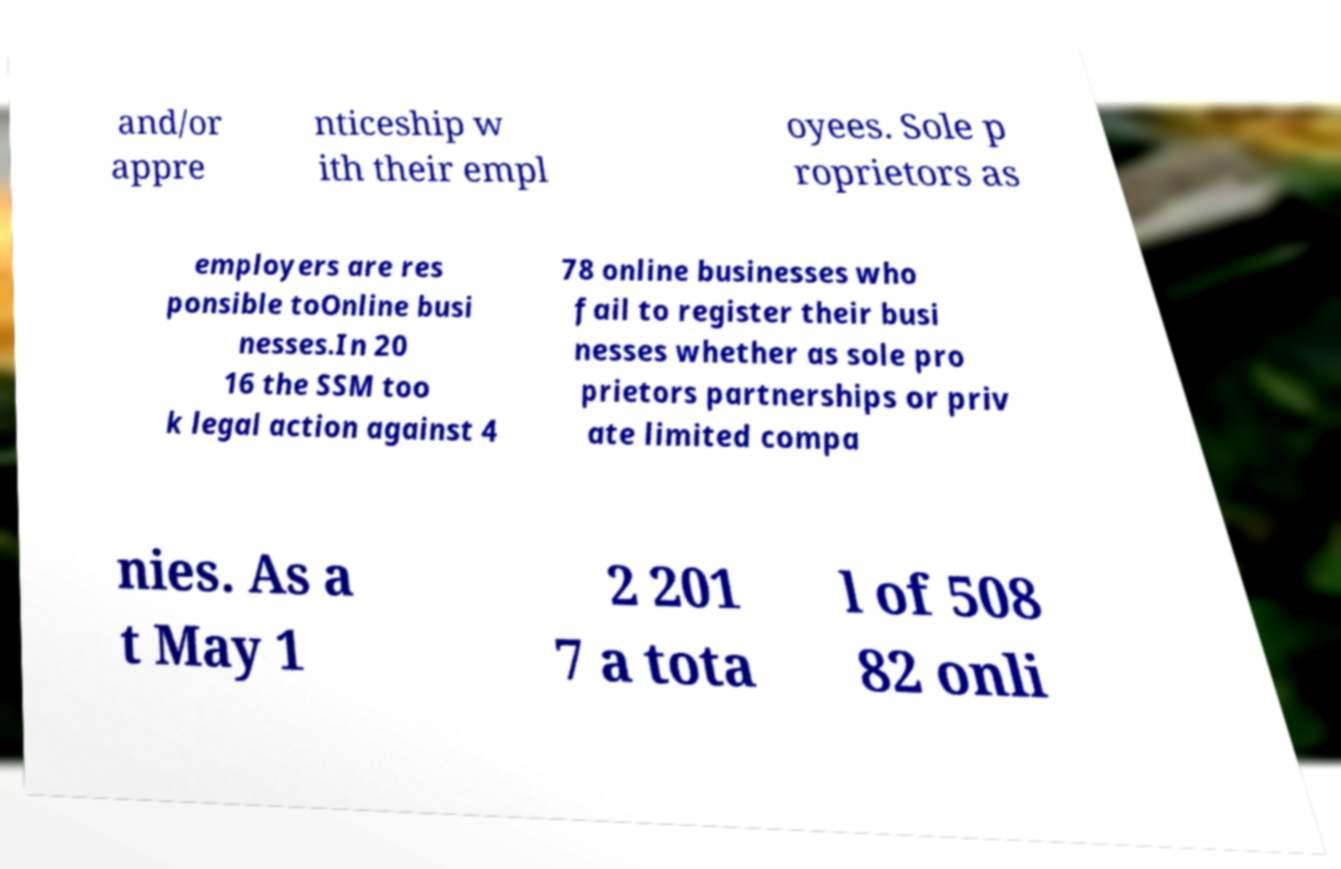Please read and relay the text visible in this image. What does it say? and/or appre nticeship w ith their empl oyees. Sole p roprietors as employers are res ponsible toOnline busi nesses.In 20 16 the SSM too k legal action against 4 78 online businesses who fail to register their busi nesses whether as sole pro prietors partnerships or priv ate limited compa nies. As a t May 1 2 201 7 a tota l of 508 82 onli 